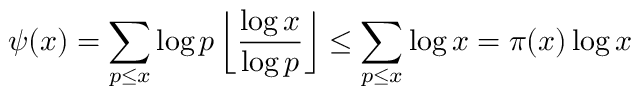Convert formula to latex. <formula><loc_0><loc_0><loc_500><loc_500>\psi ( x ) = \sum _ { p \leq x } \log p \left \lfloor { \frac { \log x } { \log p } } \right \rfloor \leq \sum _ { p \leq x } \log x = \pi ( x ) \log x</formula> 